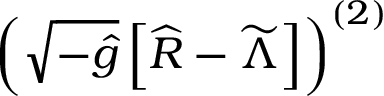Convert formula to latex. <formula><loc_0><loc_0><loc_500><loc_500>\left ( \sqrt { - { \widehat { g } } } \left [ { \widehat { R } } - { \widetilde { \Lambda } } \right ] \right ) ^ { ( 2 ) }</formula> 